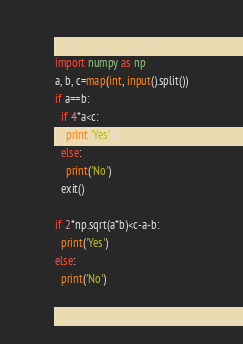Convert code to text. <code><loc_0><loc_0><loc_500><loc_500><_Python_>import numpy as np
a, b, c=map(int, input().split())
if a==b:
  if 4*a<c:
    print('Yes')
  else:
    print('No')
  exit()
  
if 2*np.sqrt(a*b)<c-a-b:
  print('Yes')
else:
  print('No')</code> 